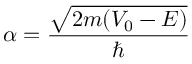Convert formula to latex. <formula><loc_0><loc_0><loc_500><loc_500>\alpha = { \frac { \sqrt { 2 m ( V _ { 0 } - E ) } } { } }</formula> 